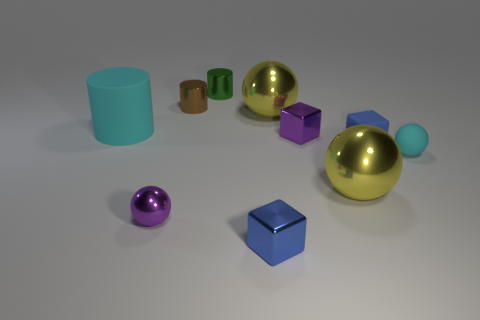Subtract all cubes. How many objects are left? 7 Subtract 0 blue cylinders. How many objects are left? 10 Subtract all brown rubber cubes. Subtract all metal balls. How many objects are left? 7 Add 5 brown metallic cylinders. How many brown metallic cylinders are left? 6 Add 2 big red shiny spheres. How many big red shiny spheres exist? 2 